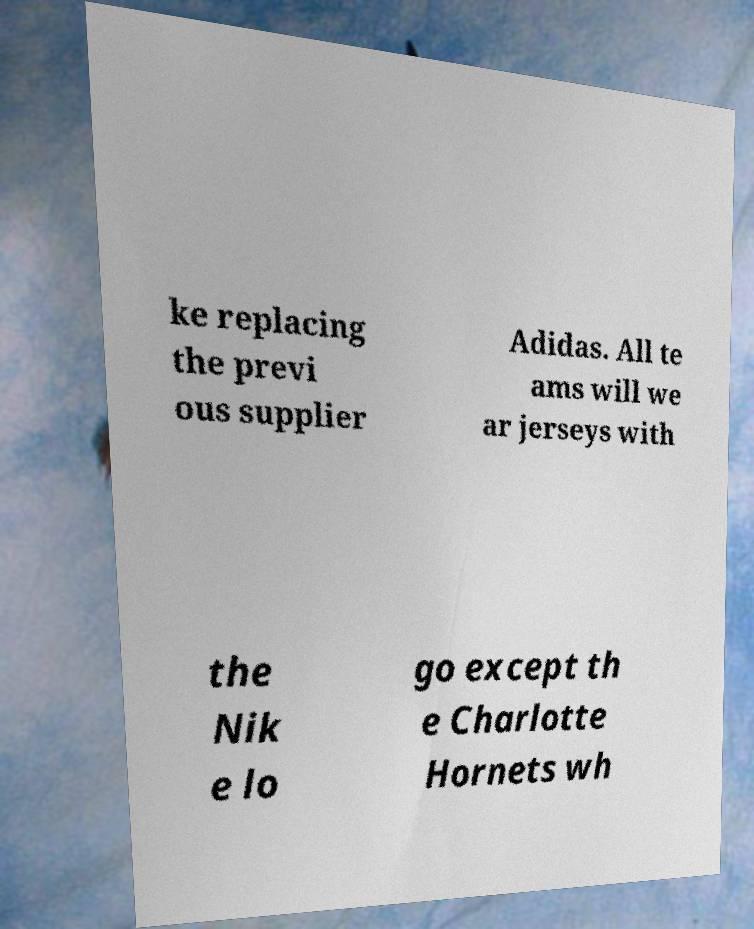I need the written content from this picture converted into text. Can you do that? ke replacing the previ ous supplier Adidas. All te ams will we ar jerseys with the Nik e lo go except th e Charlotte Hornets wh 